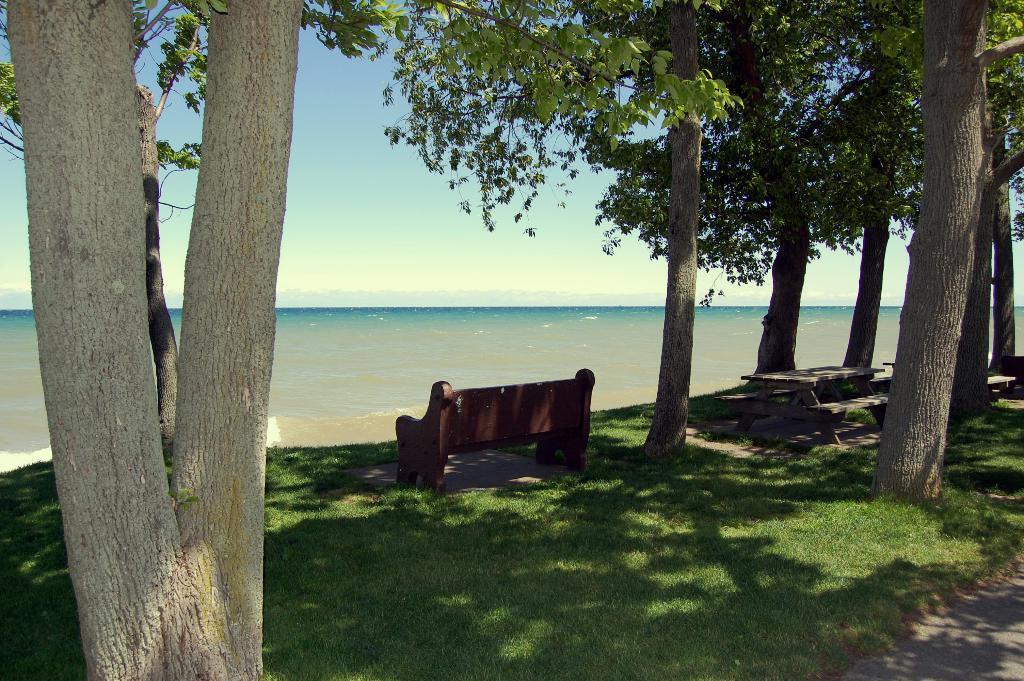In one or two sentences, can you explain what this image depicts? In this image, on the right side, we can see some trees. On the left side, we can see wooden trunk, trees. In the middle of the image, we can see a some benches. In the background, we can see water in a ocean. 